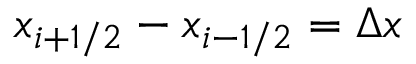Convert formula to latex. <formula><loc_0><loc_0><loc_500><loc_500>x _ { i + 1 / 2 } - x _ { i - 1 / 2 } = \Delta x</formula> 